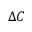Convert formula to latex. <formula><loc_0><loc_0><loc_500><loc_500>\Delta C</formula> 